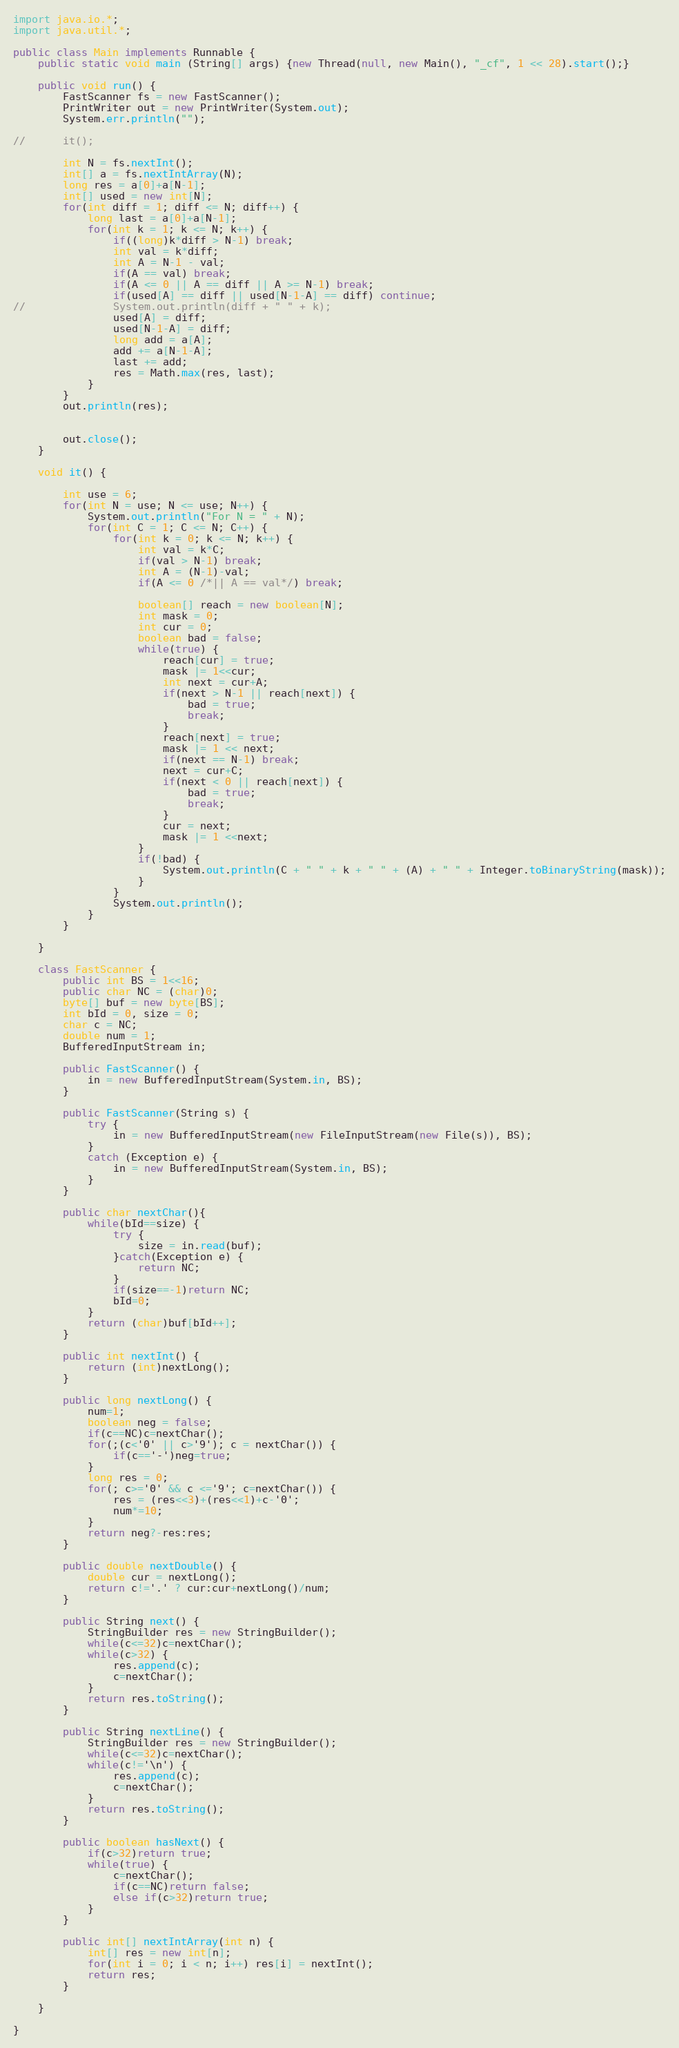Convert code to text. <code><loc_0><loc_0><loc_500><loc_500><_Java_>import java.io.*;
import java.util.*;

public class Main implements Runnable {
	public static void main (String[] args) {new Thread(null, new Main(), "_cf", 1 << 28).start();}

	public void run() {
		FastScanner fs = new FastScanner();
		PrintWriter out = new PrintWriter(System.out);
		System.err.println("");

//		it();
		
		int N = fs.nextInt();
		int[] a = fs.nextIntArray(N);
		long res = a[0]+a[N-1];
		int[] used = new int[N];
		for(int diff = 1; diff <= N; diff++) {
			long last = a[0]+a[N-1];
			for(int k = 1; k <= N; k++) {
				if((long)k*diff > N-1) break;
				int val = k*diff;
				int A = N-1 - val;
				if(A == val) break;
				if(A <= 0 || A == diff || A >= N-1) break;
				if(used[A] == diff || used[N-1-A] == diff) continue;
//				System.out.println(diff + " " + k);
				used[A] = diff;
				used[N-1-A] = diff;
				long add = a[A];
				add += a[N-1-A];
				last += add;
				res = Math.max(res, last);
			}
		}
		out.println(res);


		out.close();
	}

	void it() {

		int use = 6;
		for(int N = use; N <= use; N++) {
			System.out.println("For N = " + N);
			for(int C = 1; C <= N; C++) {
				for(int k = 0; k <= N; k++) {
					int val = k*C;
					if(val > N-1) break;
					int A = (N-1)-val;
					if(A <= 0 /*|| A == val*/) break;

					boolean[] reach = new boolean[N];
					int mask = 0;
					int cur = 0;
					boolean bad = false;
					while(true) {
						reach[cur] = true;
						mask |= 1<<cur;
						int next = cur+A;
						if(next > N-1 || reach[next]) {
							bad = true;
							break;
						}
						reach[next] = true;
						mask |= 1 << next;
						if(next == N-1) break;
						next = cur+C;
						if(next < 0 || reach[next]) {
							bad = true;
							break;
						}
						cur = next;
						mask |= 1 <<next;
					}
					if(!bad) {
						System.out.println(C + " " + k + " " + (A) + " " + Integer.toBinaryString(mask));
					}
				}
				System.out.println();
			}
		}

	}

	class FastScanner {
		public int BS = 1<<16;
		public char NC = (char)0;
		byte[] buf = new byte[BS];
		int bId = 0, size = 0;
		char c = NC;
		double num = 1;
		BufferedInputStream in;

		public FastScanner() {
			in = new BufferedInputStream(System.in, BS);
		}

		public FastScanner(String s) {
			try {
				in = new BufferedInputStream(new FileInputStream(new File(s)), BS);
			}
			catch (Exception e) {
				in = new BufferedInputStream(System.in, BS);
			}
		}

		public char nextChar(){
			while(bId==size) {
				try {
					size = in.read(buf);
				}catch(Exception e) {
					return NC;
				}                
				if(size==-1)return NC;
				bId=0;
			}
			return (char)buf[bId++];
		}

		public int nextInt() {
			return (int)nextLong();
		}

		public long nextLong() {
			num=1;
			boolean neg = false;
			if(c==NC)c=nextChar();
			for(;(c<'0' || c>'9'); c = nextChar()) {
				if(c=='-')neg=true;
			}
			long res = 0;
			for(; c>='0' && c <='9'; c=nextChar()) {
				res = (res<<3)+(res<<1)+c-'0';
				num*=10;
			}
			return neg?-res:res;
		}

		public double nextDouble() {
			double cur = nextLong();
			return c!='.' ? cur:cur+nextLong()/num;
		}

		public String next() {
			StringBuilder res = new StringBuilder();
			while(c<=32)c=nextChar();
			while(c>32) {
				res.append(c);
				c=nextChar();
			}
			return res.toString();
		}

		public String nextLine() {
			StringBuilder res = new StringBuilder();
			while(c<=32)c=nextChar();
			while(c!='\n') {
				res.append(c);
				c=nextChar();
			}
			return res.toString();
		}

		public boolean hasNext() {
			if(c>32)return true;
			while(true) {
				c=nextChar();
				if(c==NC)return false;
				else if(c>32)return true;
			}
		}

		public int[] nextIntArray(int n) {
			int[] res = new int[n];
			for(int i = 0; i < n; i++) res[i] = nextInt();
			return res;
		}

	}

}</code> 